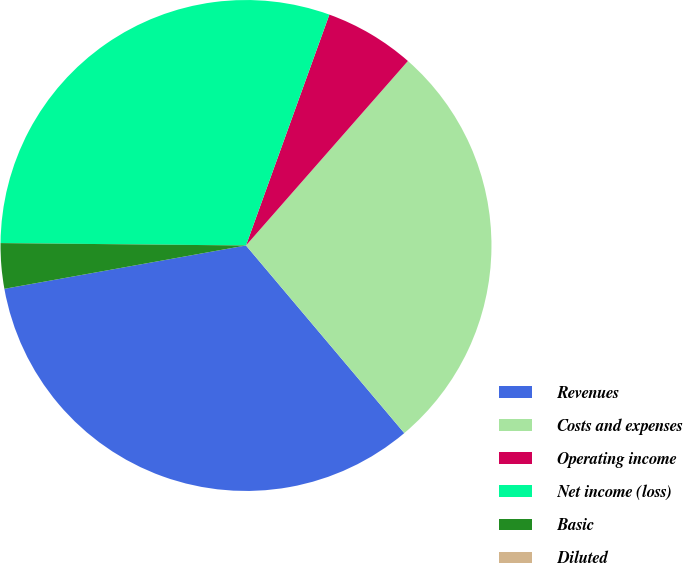Convert chart. <chart><loc_0><loc_0><loc_500><loc_500><pie_chart><fcel>Revenues<fcel>Costs and expenses<fcel>Operating income<fcel>Net income (loss)<fcel>Basic<fcel>Diluted<nl><fcel>33.33%<fcel>27.38%<fcel>5.95%<fcel>30.36%<fcel>2.98%<fcel>0.0%<nl></chart> 